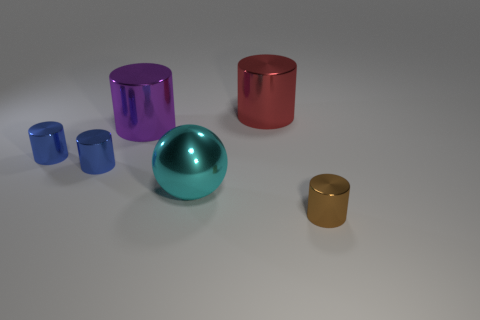Subtract all big red metallic cylinders. How many cylinders are left? 4 Subtract all purple cylinders. How many cylinders are left? 4 Subtract 1 cylinders. How many cylinders are left? 4 Subtract all brown cylinders. Subtract all red cubes. How many cylinders are left? 4 Add 2 brown matte balls. How many objects exist? 8 Subtract all spheres. How many objects are left? 5 Add 2 large purple cylinders. How many large purple cylinders are left? 3 Add 6 cyan metal spheres. How many cyan metal spheres exist? 7 Subtract 0 blue balls. How many objects are left? 6 Subtract all matte things. Subtract all brown objects. How many objects are left? 5 